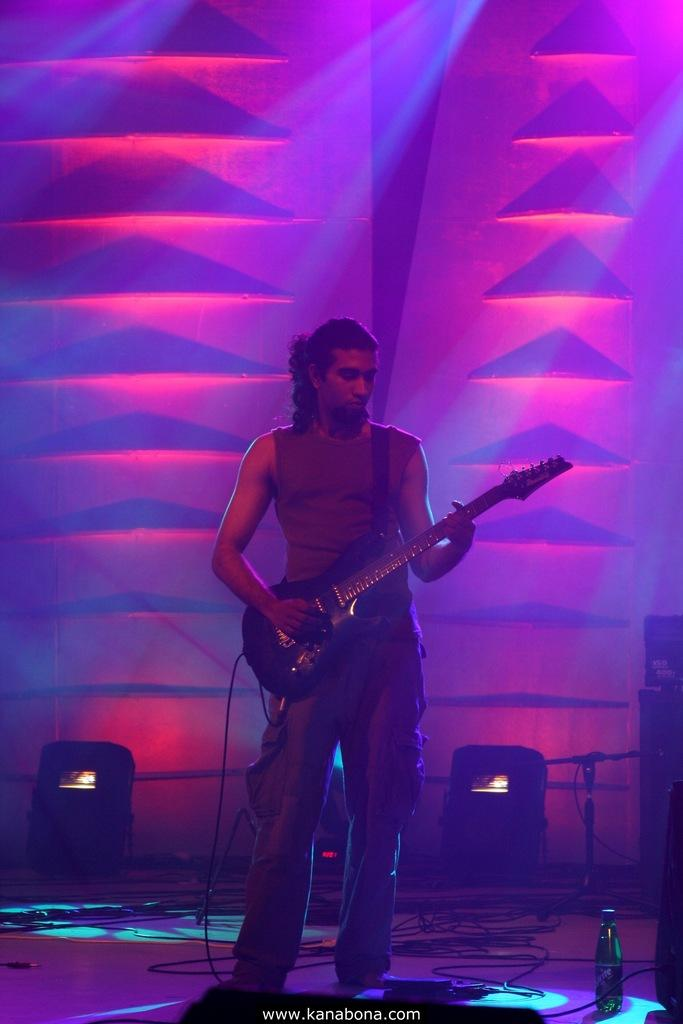What is the person in the image doing? The person is playing a guitar. What object can be seen near the person? There is a bottle in the image. What type of objects are present in the image that are related to electricity or sound? There are wires and lights in the image. What type of background is visible in the image? There is a wall in the image. Can you see any trails of mist in the image? There is no mention of trails or mist in the image; it only includes a person playing a guitar, a bottle, wires, lights, and a wall. 